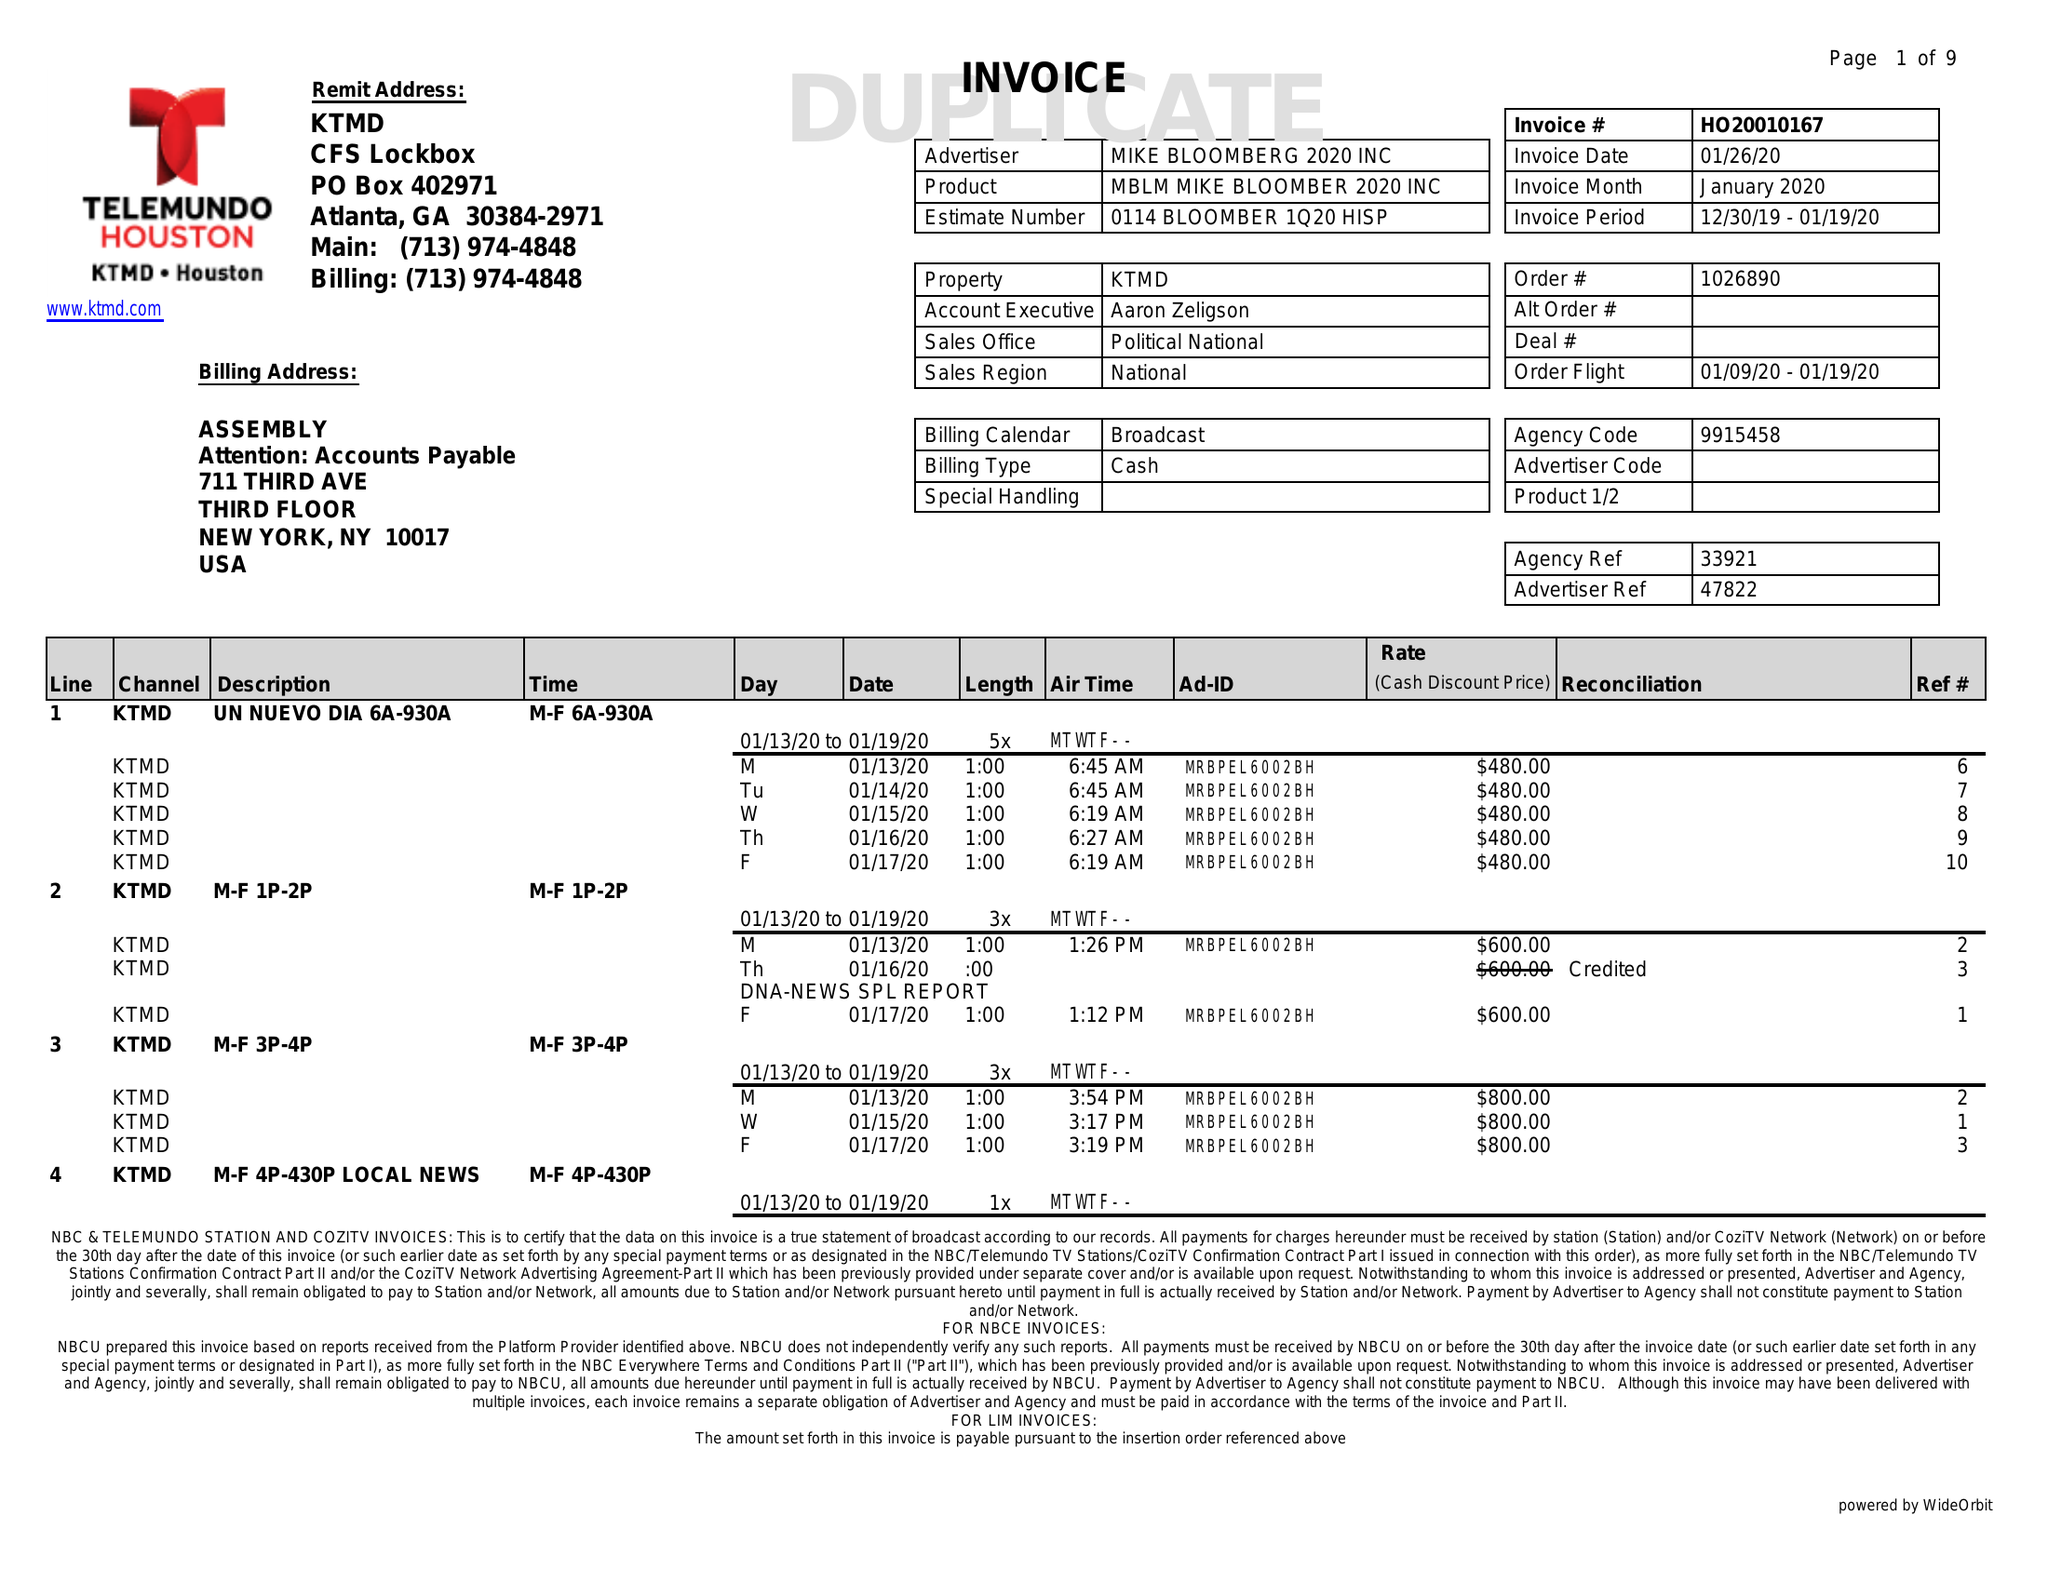What is the value for the flight_to?
Answer the question using a single word or phrase. 01/19/20 